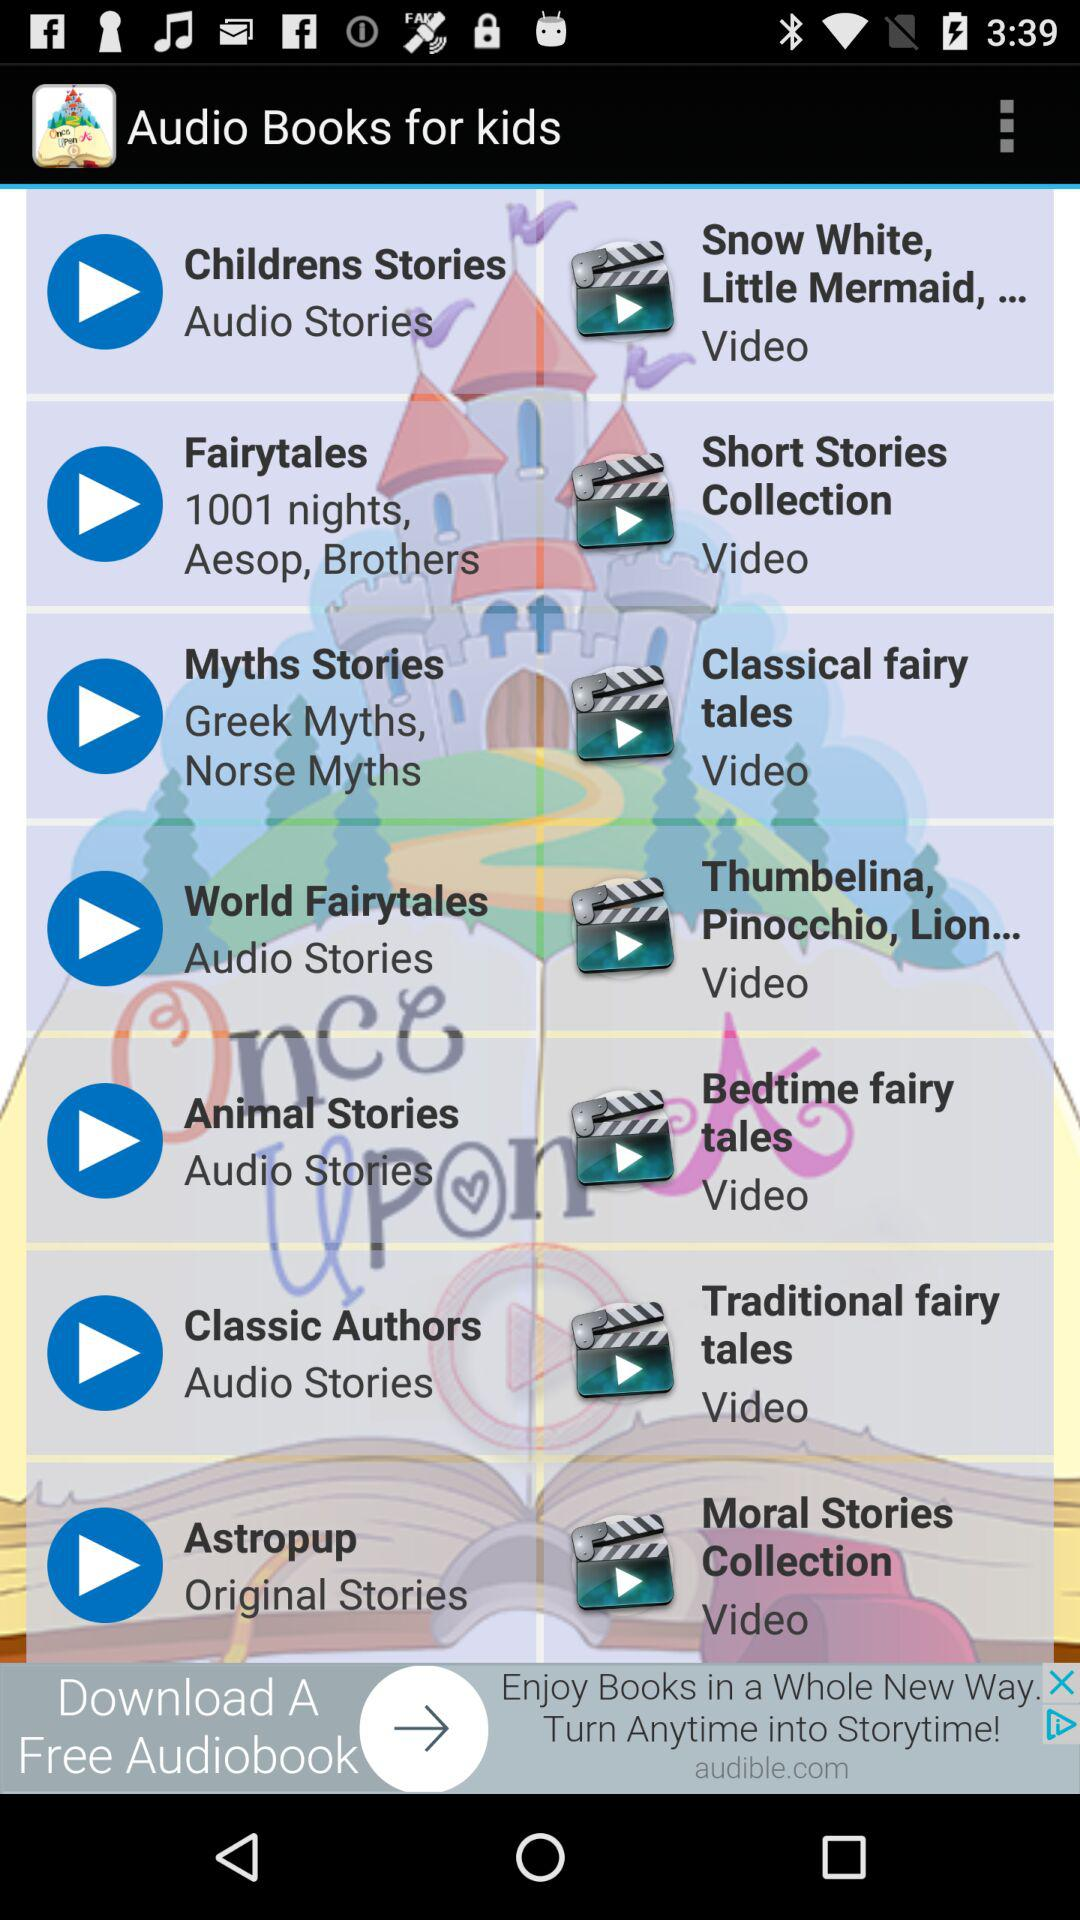Which are the different types of audio for kids? The different types of audios are: childrens stories, fairytales, myths stories, world fairytales, animal stories, classic authors and astropup. 